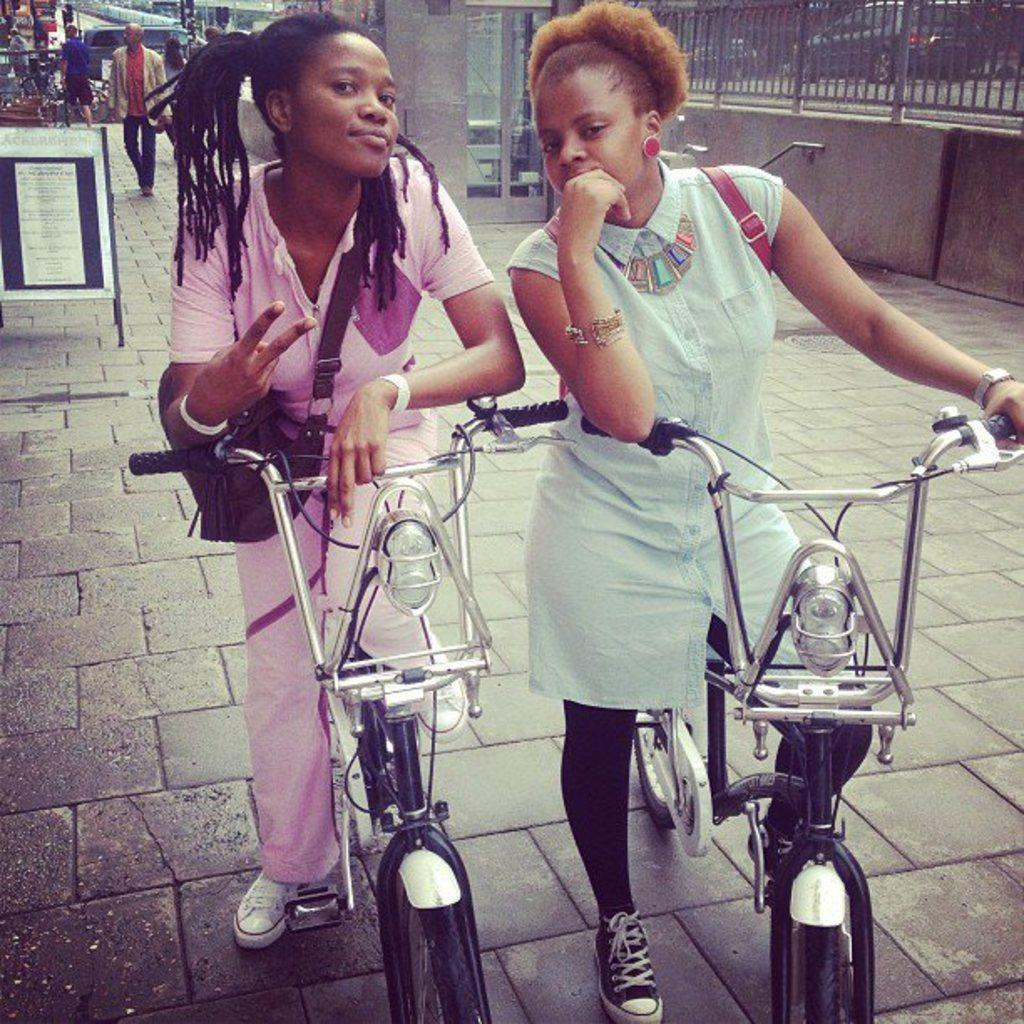How many girls are in the image? There are two girls in the image. What are the girls doing in the image? The girls are on bicycles and posing for a picture. What colors are the girls' dresses? One girl is wearing a blue dress, and the other is wearing a pink dress. What can be seen in the background of the image? There is a board in the background of the image, and a man in a white suit is walking on the road. What type of ink is being used by the flower in the image? There is no flower present in the image, so it is not possible to determine what type of ink might be used. 